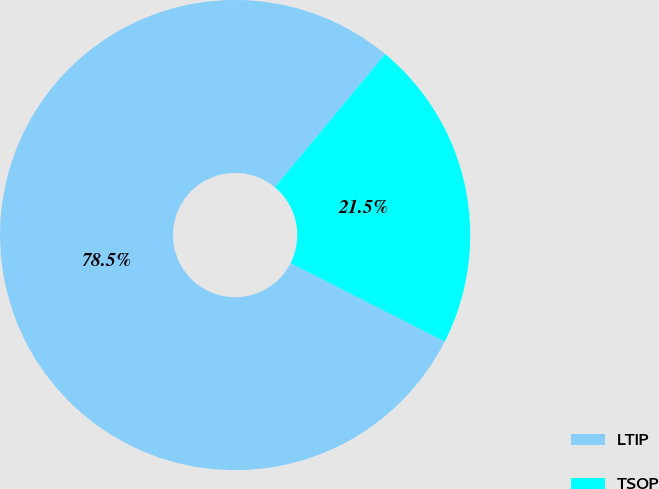<chart> <loc_0><loc_0><loc_500><loc_500><pie_chart><fcel>LTIP<fcel>TSOP<nl><fcel>78.53%<fcel>21.47%<nl></chart> 